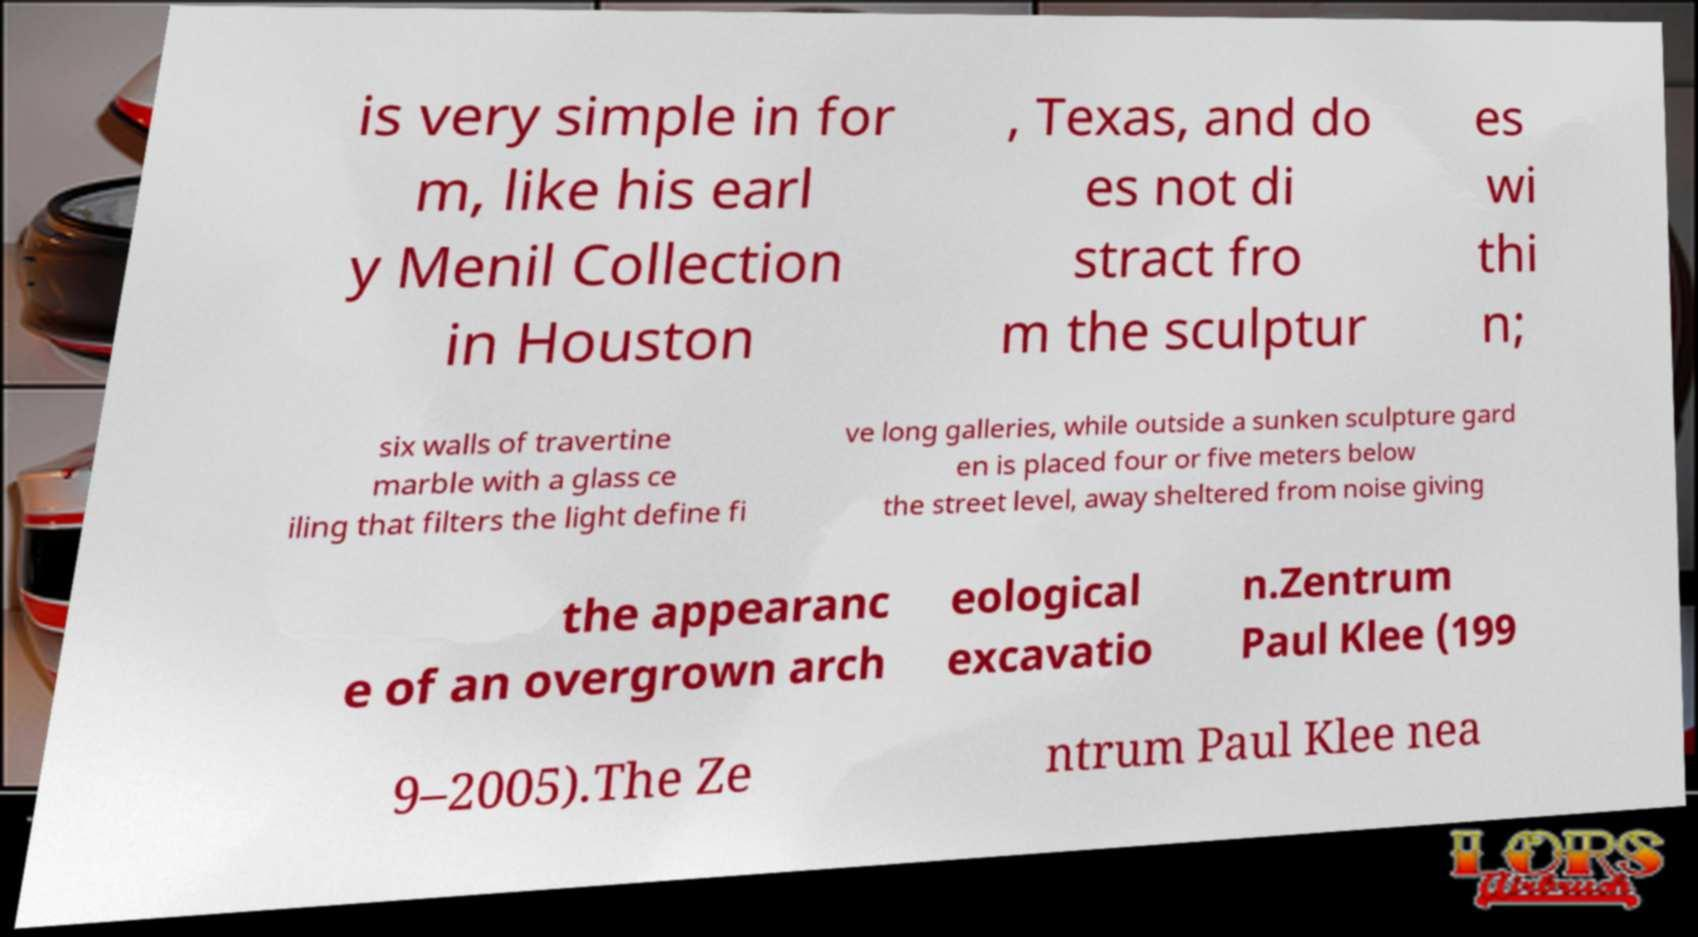Can you accurately transcribe the text from the provided image for me? is very simple in for m, like his earl y Menil Collection in Houston , Texas, and do es not di stract fro m the sculptur es wi thi n; six walls of travertine marble with a glass ce iling that filters the light define fi ve long galleries, while outside a sunken sculpture gard en is placed four or five meters below the street level, away sheltered from noise giving the appearanc e of an overgrown arch eological excavatio n.Zentrum Paul Klee (199 9–2005).The Ze ntrum Paul Klee nea 